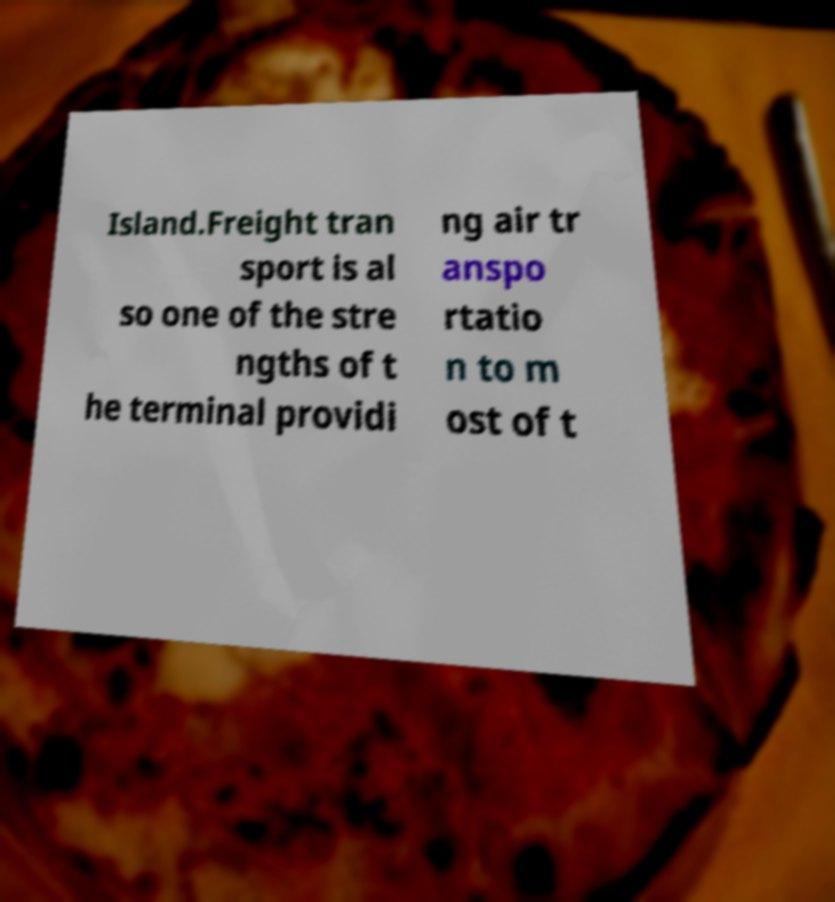What messages or text are displayed in this image? I need them in a readable, typed format. Island.Freight tran sport is al so one of the stre ngths of t he terminal providi ng air tr anspo rtatio n to m ost of t 